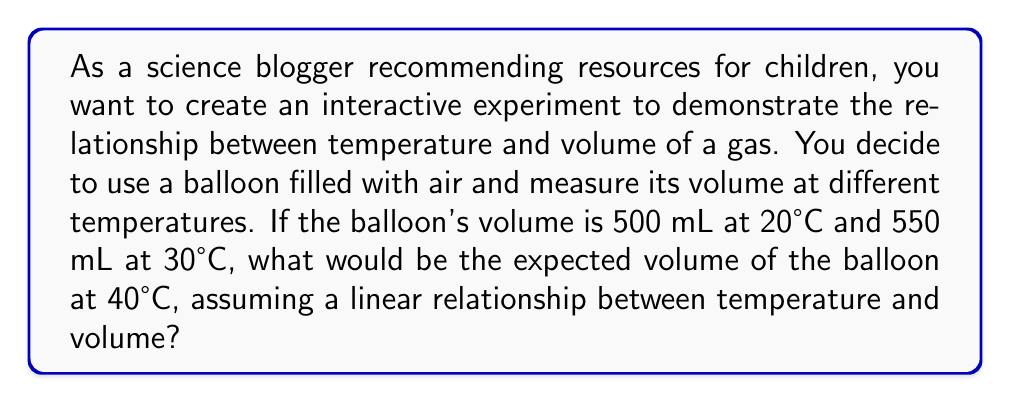Solve this math problem. Let's approach this step-by-step:

1) We're dealing with a linear relationship, so we can use the equation of a line: $y = mx + b$
   Where $y$ is the volume, $x$ is the temperature, $m$ is the slope, and $b$ is the y-intercept.

2) We have two points: (20°C, 500 mL) and (30°C, 550 mL)

3) Let's calculate the slope:
   $m = \frac{y_2 - y_1}{x_2 - x_1} = \frac{550 - 500}{30 - 20} = \frac{50}{10} = 5$ mL/°C

4) Now we can use either point to find $b$. Let's use (20, 500):
   $500 = 5(20) + b$
   $500 = 100 + b$
   $b = 400$

5) Our linear equation is: $y = 5x + 400$

6) To find the volume at 40°C, we substitute $x = 40$:
   $y = 5(40) + 400 = 200 + 400 = 600$

Therefore, at 40°C, the expected volume of the balloon would be 600 mL.
Answer: 600 mL 